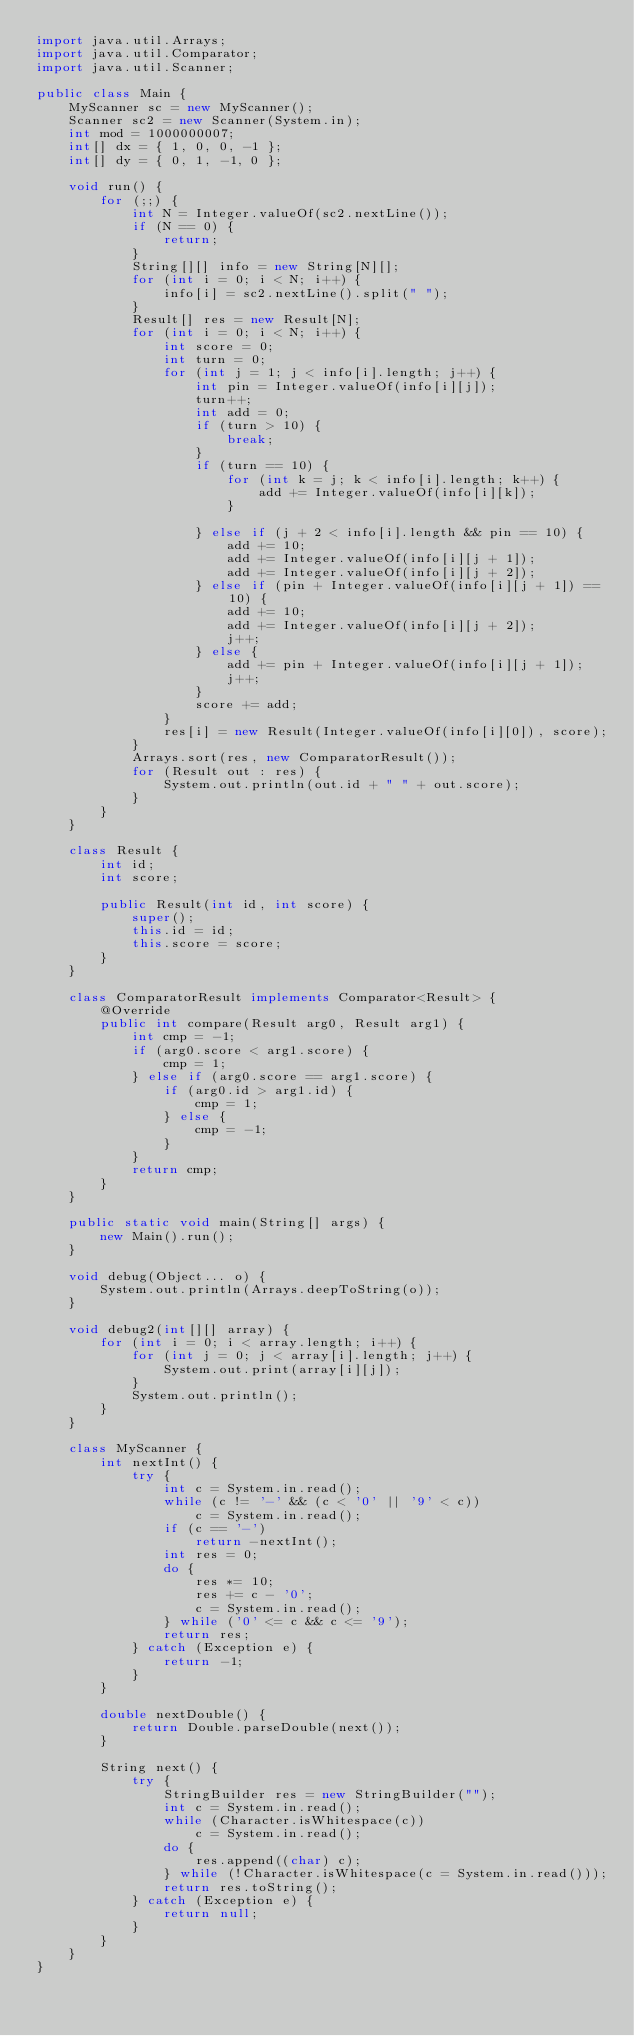Convert code to text. <code><loc_0><loc_0><loc_500><loc_500><_Java_>import java.util.Arrays;
import java.util.Comparator;
import java.util.Scanner;

public class Main {
	MyScanner sc = new MyScanner();
	Scanner sc2 = new Scanner(System.in);
	int mod = 1000000007;
	int[] dx = { 1, 0, 0, -1 };
	int[] dy = { 0, 1, -1, 0 };

	void run() {
		for (;;) {
			int N = Integer.valueOf(sc2.nextLine()); 
			if (N == 0) {
				return;
			}
			String[][] info = new String[N][];
			for (int i = 0; i < N; i++) {
				info[i] = sc2.nextLine().split(" ");
			}
			Result[] res = new Result[N];
			for (int i = 0; i < N; i++) {
				int score = 0;
				int turn = 0;
				for (int j = 1; j < info[i].length; j++) {
					int pin = Integer.valueOf(info[i][j]);
					turn++;
					int add = 0;
					if (turn > 10) {
						break;
					}
					if (turn == 10) {
						for (int k = j; k < info[i].length; k++) {
							add += Integer.valueOf(info[i][k]);
						}

					} else if (j + 2 < info[i].length && pin == 10) {
						add += 10;
						add += Integer.valueOf(info[i][j + 1]);
						add += Integer.valueOf(info[i][j + 2]);
					} else if (pin + Integer.valueOf(info[i][j + 1]) == 10) {
						add += 10;
						add += Integer.valueOf(info[i][j + 2]);
						j++;
					} else {
						add += pin + Integer.valueOf(info[i][j + 1]);
						j++;
					}
					score += add;
				}
				res[i] = new Result(Integer.valueOf(info[i][0]), score);
			}
			Arrays.sort(res, new ComparatorResult());
			for (Result out : res) {
				System.out.println(out.id + " " + out.score);
			}
		}
	}

	class Result {
		int id;
		int score;

		public Result(int id, int score) {
			super();
			this.id = id;
			this.score = score;
		}
	}

	class ComparatorResult implements Comparator<Result> {
		@Override
		public int compare(Result arg0, Result arg1) {
			int cmp = -1;
			if (arg0.score < arg1.score) {
				cmp = 1;
			} else if (arg0.score == arg1.score) {
				if (arg0.id > arg1.id) {
					cmp = 1;
				} else {
					cmp = -1;
				}
			}
			return cmp;
		}
	}

	public static void main(String[] args) {
		new Main().run();
	}

	void debug(Object... o) {
		System.out.println(Arrays.deepToString(o));
	}

	void debug2(int[][] array) {
		for (int i = 0; i < array.length; i++) {
			for (int j = 0; j < array[i].length; j++) {
				System.out.print(array[i][j]);
			}
			System.out.println();
		}
	}

	class MyScanner {
		int nextInt() {
			try {
				int c = System.in.read();
				while (c != '-' && (c < '0' || '9' < c))
					c = System.in.read();
				if (c == '-')
					return -nextInt();
				int res = 0;
				do {
					res *= 10;
					res += c - '0';
					c = System.in.read();
				} while ('0' <= c && c <= '9');
				return res;
			} catch (Exception e) {
				return -1;
			}
		}

		double nextDouble() {
			return Double.parseDouble(next());
		}

		String next() {
			try {
				StringBuilder res = new StringBuilder("");
				int c = System.in.read();
				while (Character.isWhitespace(c))
					c = System.in.read();
				do {
					res.append((char) c);
				} while (!Character.isWhitespace(c = System.in.read()));
				return res.toString();
			} catch (Exception e) {
				return null;
			}
		}
	}
}</code> 